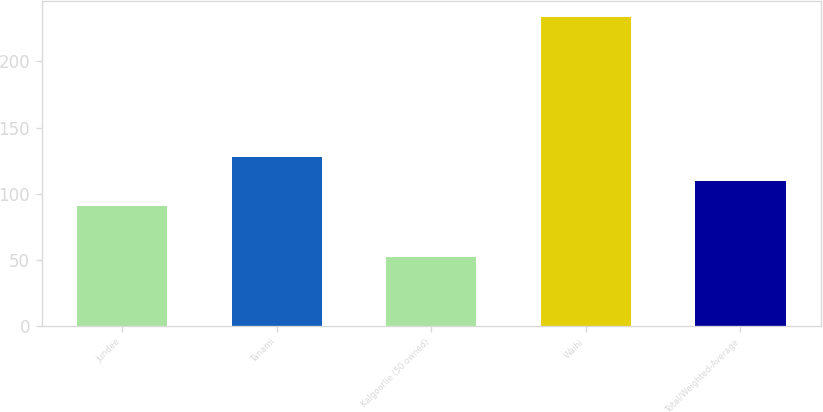<chart> <loc_0><loc_0><loc_500><loc_500><bar_chart><fcel>Jundee<fcel>Tanami<fcel>Kalgoorlie (50 owned)<fcel>Waihi<fcel>Total/Weighted-Average<nl><fcel>91<fcel>127.4<fcel>52<fcel>234<fcel>109.2<nl></chart> 